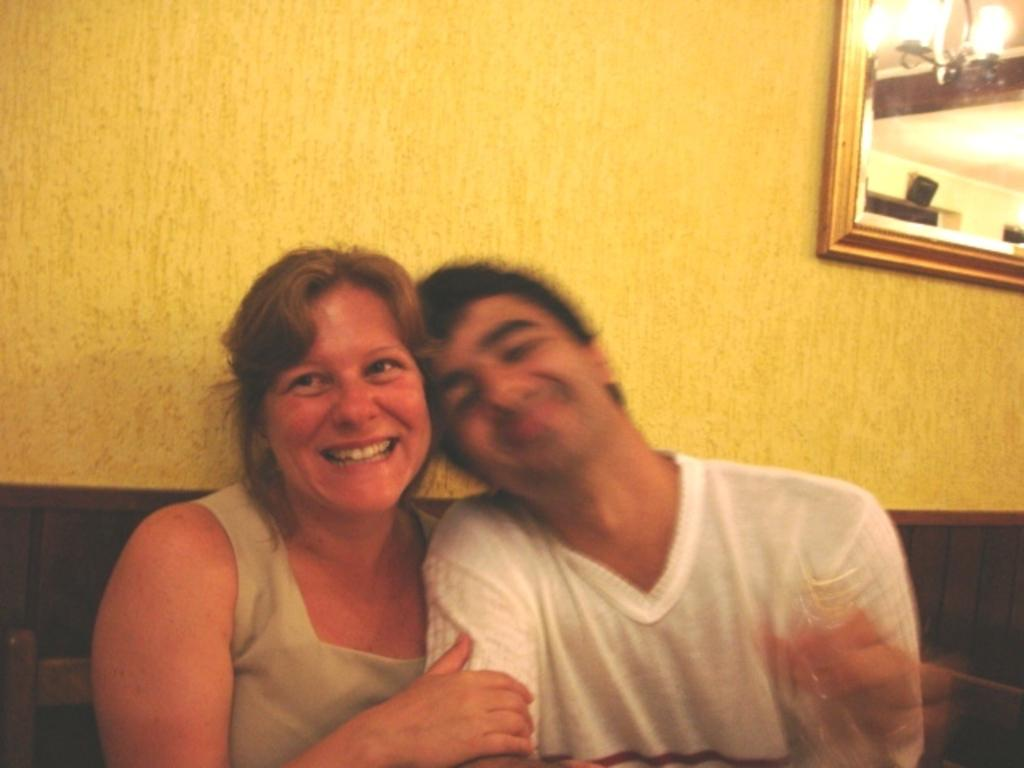How many people are present in the image? There are two people, a man and a woman, present in the image. What are the man and woman doing in the image? The woman is holding hands with the man. What can be seen on the wall in the image? There is a frame on the wall in the image. What language is the wax ear speaking in the image? There is no wax ear present in the image, so it is not possible to determine what language it might be speaking. 